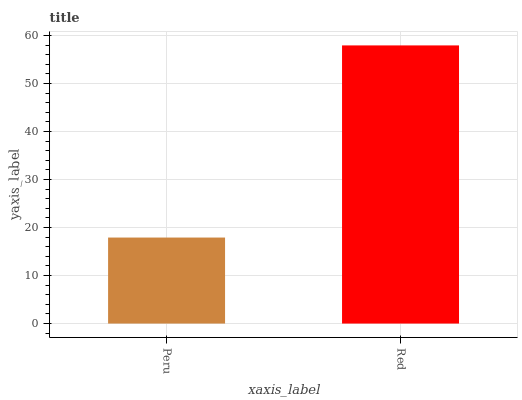Is Peru the minimum?
Answer yes or no. Yes. Is Red the maximum?
Answer yes or no. Yes. Is Red the minimum?
Answer yes or no. No. Is Red greater than Peru?
Answer yes or no. Yes. Is Peru less than Red?
Answer yes or no. Yes. Is Peru greater than Red?
Answer yes or no. No. Is Red less than Peru?
Answer yes or no. No. Is Red the high median?
Answer yes or no. Yes. Is Peru the low median?
Answer yes or no. Yes. Is Peru the high median?
Answer yes or no. No. Is Red the low median?
Answer yes or no. No. 